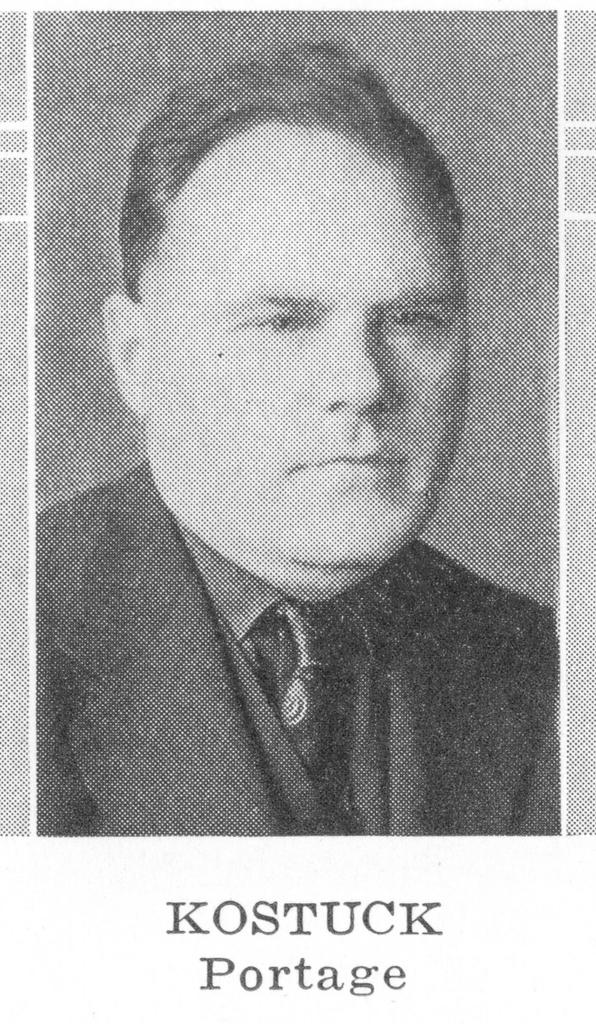What is the main subject of the image? The main subject of the image is a picture of a man. Is there any text associated with the image? Yes, there is text at the bottom of the image. What type of arm is the man holding in the image? There is no arm visible in the image; it only shows a picture of a man. 